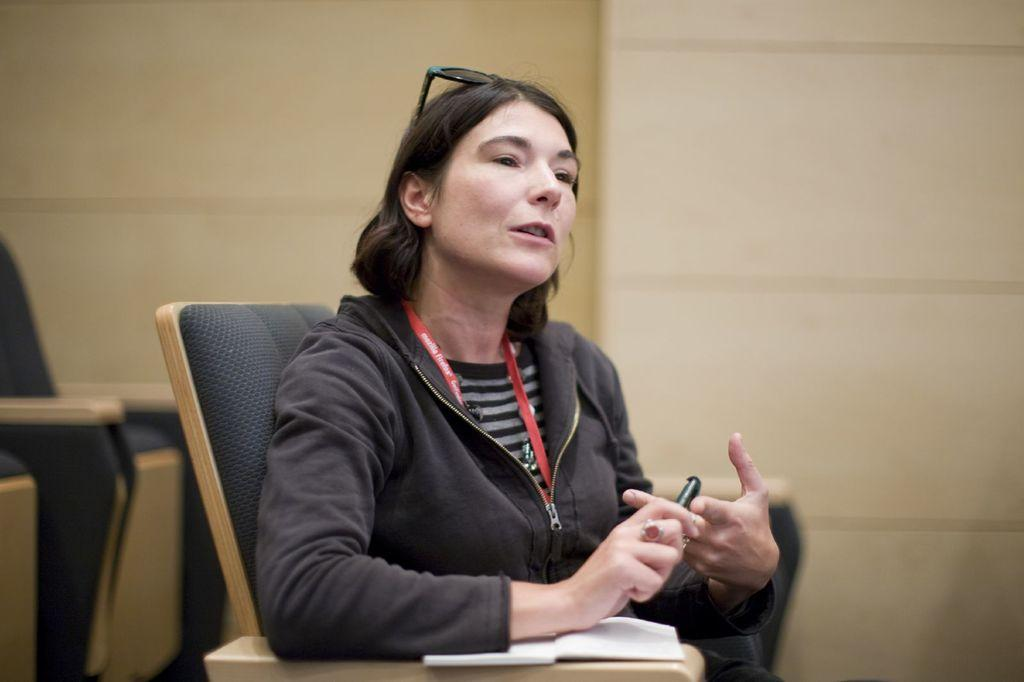Where was the image taken? The image was taken in a room. Who is present in the image? There is a woman in the image. What is the woman wearing? The woman is wearing a black jacket. What is the woman doing in the image? The woman is sitting on a chair and holding a pen. What is the woman interacting with in the image? The woman is holding a pen and there is a book under her hand. What can be seen behind the woman in the image? There is a wall behind the woman. Can you see any clouds in the image? No, there are no clouds visible in the image, as it was taken indoors in a room. Is there a man present in the image? No, there is no man present in the image; it features a woman. 